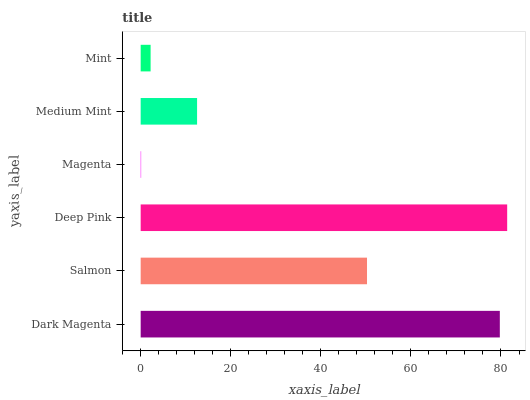Is Magenta the minimum?
Answer yes or no. Yes. Is Deep Pink the maximum?
Answer yes or no. Yes. Is Salmon the minimum?
Answer yes or no. No. Is Salmon the maximum?
Answer yes or no. No. Is Dark Magenta greater than Salmon?
Answer yes or no. Yes. Is Salmon less than Dark Magenta?
Answer yes or no. Yes. Is Salmon greater than Dark Magenta?
Answer yes or no. No. Is Dark Magenta less than Salmon?
Answer yes or no. No. Is Salmon the high median?
Answer yes or no. Yes. Is Medium Mint the low median?
Answer yes or no. Yes. Is Mint the high median?
Answer yes or no. No. Is Mint the low median?
Answer yes or no. No. 